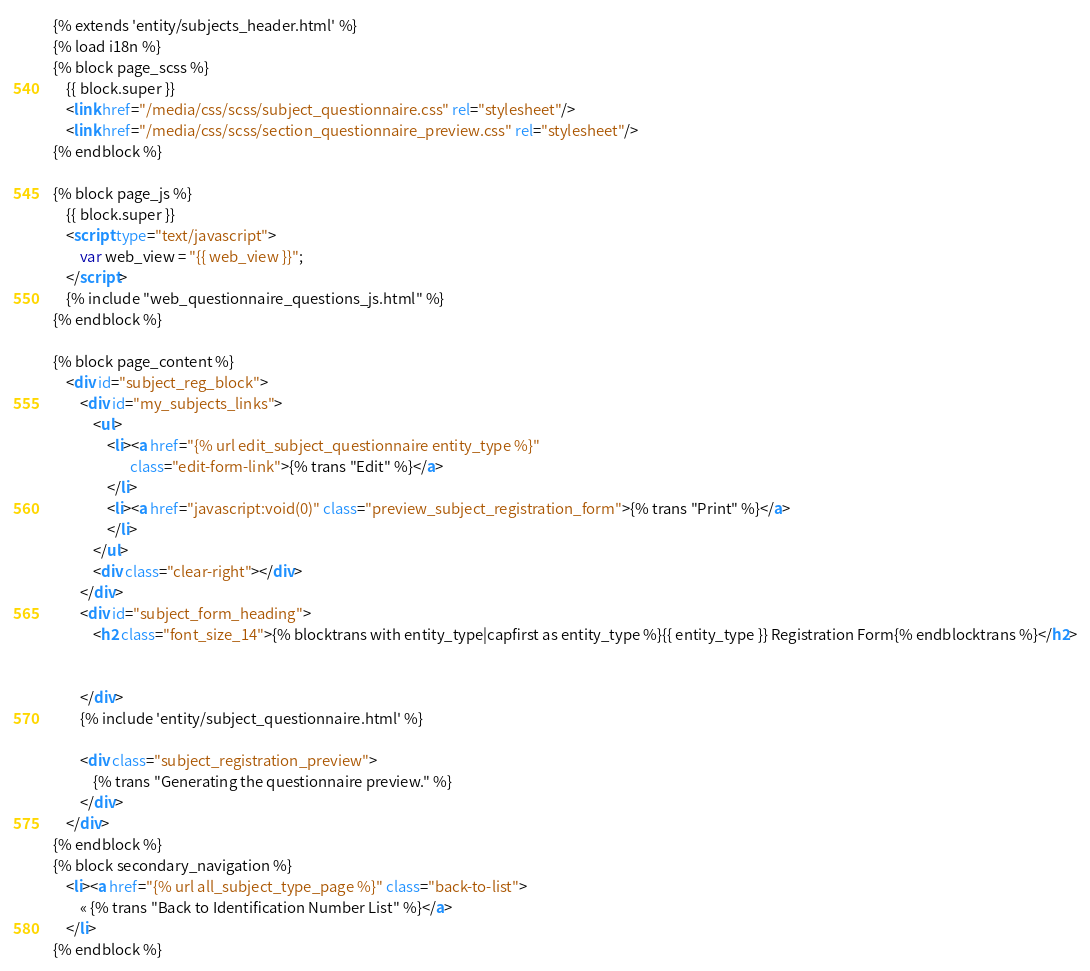Convert code to text. <code><loc_0><loc_0><loc_500><loc_500><_HTML_>{% extends 'entity/subjects_header.html' %}
{% load i18n %}
{% block page_scss %}
    {{ block.super }}
    <link href="/media/css/scss/subject_questionnaire.css" rel="stylesheet"/>
    <link href="/media/css/scss/section_questionnaire_preview.css" rel="stylesheet"/>
{% endblock %}

{% block page_js %}
    {{ block.super }}
    <script type="text/javascript">
        var web_view = "{{ web_view }}";
    </script>
    {% include "web_questionnaire_questions_js.html" %}
{% endblock %}

{% block page_content %}
    <div id="subject_reg_block">
        <div id="my_subjects_links">
            <ul>
                <li><a href="{% url edit_subject_questionnaire entity_type %}"
                       class="edit-form-link">{% trans "Edit" %}</a>
                </li>
                <li><a href="javascript:void(0)" class="preview_subject_registration_form">{% trans "Print" %}</a>
                </li>
            </ul>
            <div class="clear-right"></div>
        </div>
        <div id="subject_form_heading">
            <h2 class="font_size_14">{% blocktrans with entity_type|capfirst as entity_type %}{{ entity_type }} Registration Form{% endblocktrans %}</h2>


        </div>
        {% include 'entity/subject_questionnaire.html' %}

        <div class="subject_registration_preview">
            {% trans "Generating the questionnaire preview." %}
        </div>
    </div>
{% endblock %}
{% block secondary_navigation %}
    <li><a href="{% url all_subject_type_page %}" class="back-to-list">
        « {% trans "Back to Identification Number List" %}</a>
    </li>
{% endblock %}</code> 